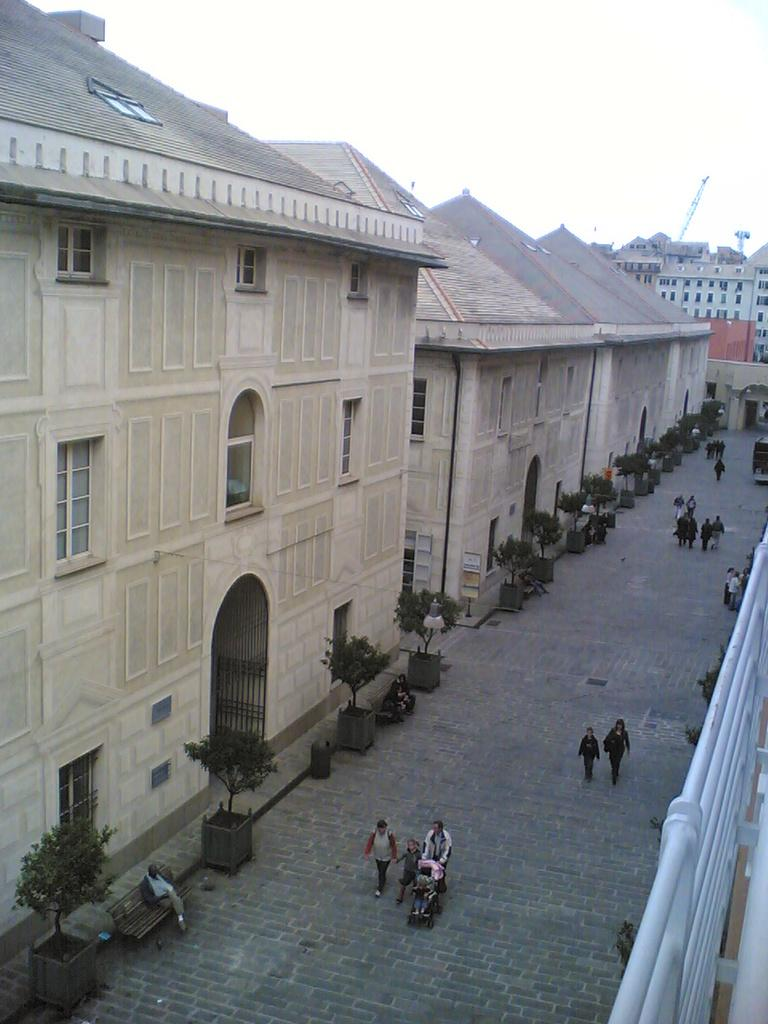What are the people in the image doing? The people in the image are walking. On what surface are the people walking? The people are walking on the ground. What can be seen in the background of the image? There are buildings, trees, and the sky visible in the background of the image. Are there any other objects present in the background of the image? Yes, there are other objects present in the background of the image. What type of jeans is the crib wearing in the image? There is no crib or jeans present in the image; it features people walking on the ground with buildings, trees, and the sky in the background. Is there a basketball game happening in the image? There is no basketball game or any reference to a basketball in the image. 